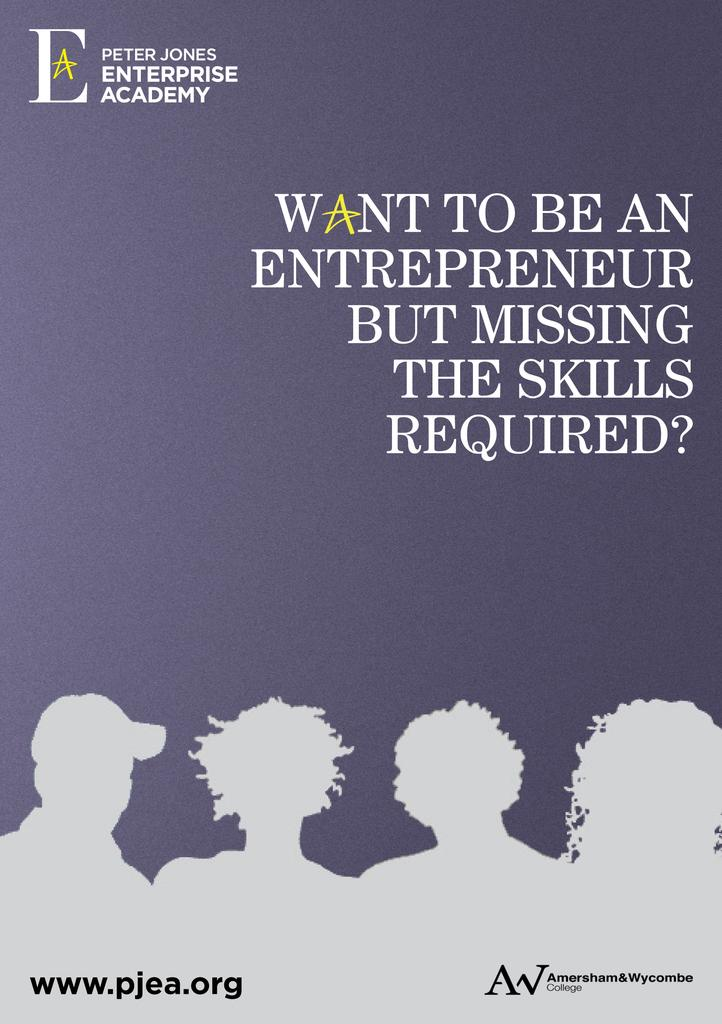<image>
Render a clear and concise summary of the photo. An advertisement for the Peter Jones Enterprise Academy. 